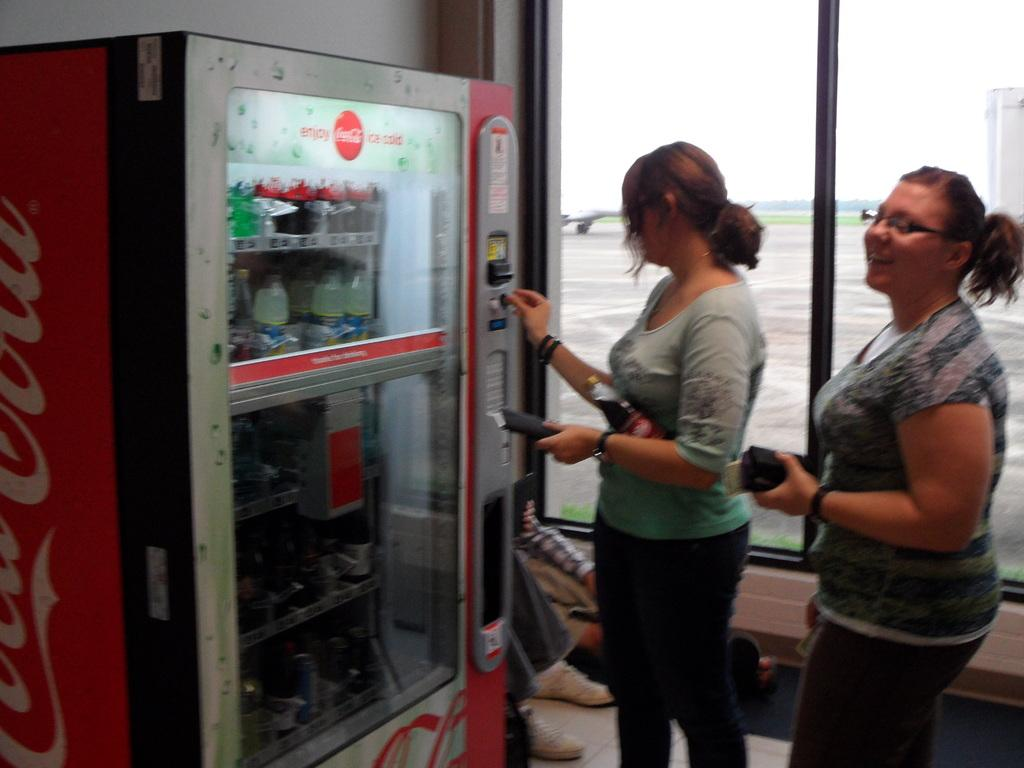<image>
Give a short and clear explanation of the subsequent image. Some women buy beverages from a Coca Cola vending machine. 